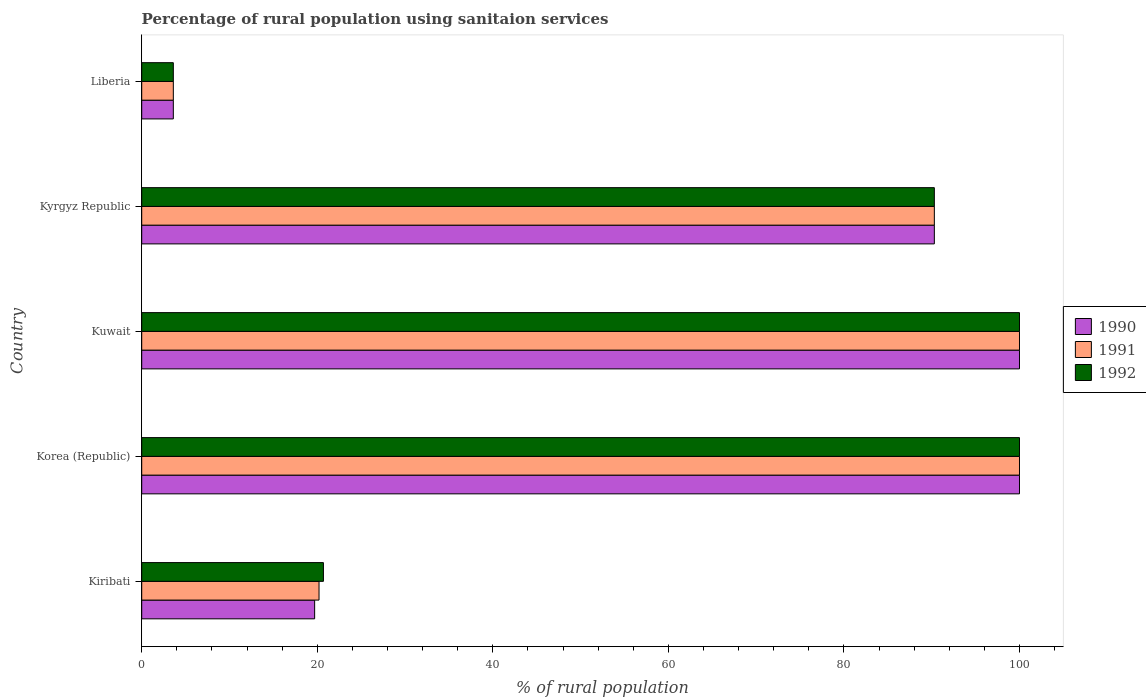Are the number of bars on each tick of the Y-axis equal?
Keep it short and to the point. Yes. How many bars are there on the 3rd tick from the top?
Make the answer very short. 3. How many bars are there on the 3rd tick from the bottom?
Your response must be concise. 3. What is the label of the 3rd group of bars from the top?
Your answer should be compact. Kuwait. What is the percentage of rural population using sanitaion services in 1990 in Kuwait?
Offer a very short reply. 100. In which country was the percentage of rural population using sanitaion services in 1992 maximum?
Offer a terse response. Korea (Republic). In which country was the percentage of rural population using sanitaion services in 1990 minimum?
Keep it short and to the point. Liberia. What is the total percentage of rural population using sanitaion services in 1992 in the graph?
Make the answer very short. 314.6. What is the difference between the percentage of rural population using sanitaion services in 1991 in Korea (Republic) and that in Kyrgyz Republic?
Offer a terse response. 9.7. What is the difference between the percentage of rural population using sanitaion services in 1991 in Kiribati and the percentage of rural population using sanitaion services in 1992 in Kyrgyz Republic?
Your answer should be compact. -70.1. What is the average percentage of rural population using sanitaion services in 1992 per country?
Make the answer very short. 62.92. What is the difference between the percentage of rural population using sanitaion services in 1990 and percentage of rural population using sanitaion services in 1992 in Liberia?
Your answer should be compact. 0. In how many countries, is the percentage of rural population using sanitaion services in 1990 greater than 44 %?
Ensure brevity in your answer.  3. What is the ratio of the percentage of rural population using sanitaion services in 1991 in Kuwait to that in Liberia?
Offer a terse response. 27.78. Is the percentage of rural population using sanitaion services in 1990 in Kiribati less than that in Liberia?
Provide a succinct answer. No. What is the difference between the highest and the second highest percentage of rural population using sanitaion services in 1991?
Make the answer very short. 0. What is the difference between the highest and the lowest percentage of rural population using sanitaion services in 1990?
Make the answer very short. 96.4. In how many countries, is the percentage of rural population using sanitaion services in 1992 greater than the average percentage of rural population using sanitaion services in 1992 taken over all countries?
Provide a succinct answer. 3. What does the 2nd bar from the bottom in Kiribati represents?
Give a very brief answer. 1991. Is it the case that in every country, the sum of the percentage of rural population using sanitaion services in 1992 and percentage of rural population using sanitaion services in 1990 is greater than the percentage of rural population using sanitaion services in 1991?
Ensure brevity in your answer.  Yes. How many bars are there?
Make the answer very short. 15. Are all the bars in the graph horizontal?
Your response must be concise. Yes. What is the difference between two consecutive major ticks on the X-axis?
Your answer should be very brief. 20. Does the graph contain any zero values?
Your response must be concise. No. Where does the legend appear in the graph?
Your answer should be compact. Center right. How many legend labels are there?
Ensure brevity in your answer.  3. What is the title of the graph?
Keep it short and to the point. Percentage of rural population using sanitaion services. What is the label or title of the X-axis?
Ensure brevity in your answer.  % of rural population. What is the % of rural population in 1991 in Kiribati?
Make the answer very short. 20.2. What is the % of rural population of 1992 in Kiribati?
Provide a short and direct response. 20.7. What is the % of rural population in 1990 in Korea (Republic)?
Ensure brevity in your answer.  100. What is the % of rural population in 1992 in Korea (Republic)?
Ensure brevity in your answer.  100. What is the % of rural population of 1990 in Kuwait?
Provide a short and direct response. 100. What is the % of rural population of 1992 in Kuwait?
Your answer should be compact. 100. What is the % of rural population of 1990 in Kyrgyz Republic?
Offer a terse response. 90.3. What is the % of rural population in 1991 in Kyrgyz Republic?
Ensure brevity in your answer.  90.3. What is the % of rural population of 1992 in Kyrgyz Republic?
Your response must be concise. 90.3. What is the % of rural population of 1990 in Liberia?
Provide a succinct answer. 3.6. Across all countries, what is the maximum % of rural population in 1991?
Your response must be concise. 100. Across all countries, what is the maximum % of rural population of 1992?
Keep it short and to the point. 100. Across all countries, what is the minimum % of rural population in 1991?
Your answer should be compact. 3.6. Across all countries, what is the minimum % of rural population of 1992?
Your answer should be compact. 3.6. What is the total % of rural population of 1990 in the graph?
Your response must be concise. 313.6. What is the total % of rural population of 1991 in the graph?
Your response must be concise. 314.1. What is the total % of rural population of 1992 in the graph?
Keep it short and to the point. 314.6. What is the difference between the % of rural population of 1990 in Kiribati and that in Korea (Republic)?
Ensure brevity in your answer.  -80.3. What is the difference between the % of rural population of 1991 in Kiribati and that in Korea (Republic)?
Your answer should be compact. -79.8. What is the difference between the % of rural population in 1992 in Kiribati and that in Korea (Republic)?
Give a very brief answer. -79.3. What is the difference between the % of rural population in 1990 in Kiribati and that in Kuwait?
Ensure brevity in your answer.  -80.3. What is the difference between the % of rural population in 1991 in Kiribati and that in Kuwait?
Provide a short and direct response. -79.8. What is the difference between the % of rural population in 1992 in Kiribati and that in Kuwait?
Provide a short and direct response. -79.3. What is the difference between the % of rural population in 1990 in Kiribati and that in Kyrgyz Republic?
Ensure brevity in your answer.  -70.6. What is the difference between the % of rural population in 1991 in Kiribati and that in Kyrgyz Republic?
Your answer should be compact. -70.1. What is the difference between the % of rural population in 1992 in Kiribati and that in Kyrgyz Republic?
Your response must be concise. -69.6. What is the difference between the % of rural population in 1990 in Korea (Republic) and that in Kuwait?
Provide a short and direct response. 0. What is the difference between the % of rural population in 1991 in Korea (Republic) and that in Kuwait?
Make the answer very short. 0. What is the difference between the % of rural population of 1992 in Korea (Republic) and that in Kuwait?
Keep it short and to the point. 0. What is the difference between the % of rural population in 1990 in Korea (Republic) and that in Kyrgyz Republic?
Offer a very short reply. 9.7. What is the difference between the % of rural population of 1991 in Korea (Republic) and that in Kyrgyz Republic?
Your answer should be very brief. 9.7. What is the difference between the % of rural population of 1992 in Korea (Republic) and that in Kyrgyz Republic?
Your answer should be very brief. 9.7. What is the difference between the % of rural population of 1990 in Korea (Republic) and that in Liberia?
Make the answer very short. 96.4. What is the difference between the % of rural population in 1991 in Korea (Republic) and that in Liberia?
Provide a succinct answer. 96.4. What is the difference between the % of rural population in 1992 in Korea (Republic) and that in Liberia?
Your answer should be very brief. 96.4. What is the difference between the % of rural population in 1990 in Kuwait and that in Kyrgyz Republic?
Your response must be concise. 9.7. What is the difference between the % of rural population of 1991 in Kuwait and that in Kyrgyz Republic?
Your answer should be compact. 9.7. What is the difference between the % of rural population in 1992 in Kuwait and that in Kyrgyz Republic?
Keep it short and to the point. 9.7. What is the difference between the % of rural population in 1990 in Kuwait and that in Liberia?
Keep it short and to the point. 96.4. What is the difference between the % of rural population of 1991 in Kuwait and that in Liberia?
Offer a terse response. 96.4. What is the difference between the % of rural population in 1992 in Kuwait and that in Liberia?
Your response must be concise. 96.4. What is the difference between the % of rural population in 1990 in Kyrgyz Republic and that in Liberia?
Offer a terse response. 86.7. What is the difference between the % of rural population of 1991 in Kyrgyz Republic and that in Liberia?
Give a very brief answer. 86.7. What is the difference between the % of rural population of 1992 in Kyrgyz Republic and that in Liberia?
Keep it short and to the point. 86.7. What is the difference between the % of rural population of 1990 in Kiribati and the % of rural population of 1991 in Korea (Republic)?
Give a very brief answer. -80.3. What is the difference between the % of rural population in 1990 in Kiribati and the % of rural population in 1992 in Korea (Republic)?
Provide a short and direct response. -80.3. What is the difference between the % of rural population in 1991 in Kiribati and the % of rural population in 1992 in Korea (Republic)?
Offer a very short reply. -79.8. What is the difference between the % of rural population of 1990 in Kiribati and the % of rural population of 1991 in Kuwait?
Keep it short and to the point. -80.3. What is the difference between the % of rural population of 1990 in Kiribati and the % of rural population of 1992 in Kuwait?
Offer a terse response. -80.3. What is the difference between the % of rural population in 1991 in Kiribati and the % of rural population in 1992 in Kuwait?
Your response must be concise. -79.8. What is the difference between the % of rural population in 1990 in Kiribati and the % of rural population in 1991 in Kyrgyz Republic?
Offer a terse response. -70.6. What is the difference between the % of rural population of 1990 in Kiribati and the % of rural population of 1992 in Kyrgyz Republic?
Your answer should be compact. -70.6. What is the difference between the % of rural population in 1991 in Kiribati and the % of rural population in 1992 in Kyrgyz Republic?
Offer a terse response. -70.1. What is the difference between the % of rural population in 1991 in Korea (Republic) and the % of rural population in 1992 in Kuwait?
Make the answer very short. 0. What is the difference between the % of rural population in 1990 in Korea (Republic) and the % of rural population in 1991 in Kyrgyz Republic?
Your answer should be very brief. 9.7. What is the difference between the % of rural population of 1991 in Korea (Republic) and the % of rural population of 1992 in Kyrgyz Republic?
Offer a very short reply. 9.7. What is the difference between the % of rural population in 1990 in Korea (Republic) and the % of rural population in 1991 in Liberia?
Make the answer very short. 96.4. What is the difference between the % of rural population in 1990 in Korea (Republic) and the % of rural population in 1992 in Liberia?
Ensure brevity in your answer.  96.4. What is the difference between the % of rural population in 1991 in Korea (Republic) and the % of rural population in 1992 in Liberia?
Provide a succinct answer. 96.4. What is the difference between the % of rural population in 1990 in Kuwait and the % of rural population in 1991 in Kyrgyz Republic?
Provide a short and direct response. 9.7. What is the difference between the % of rural population in 1991 in Kuwait and the % of rural population in 1992 in Kyrgyz Republic?
Provide a succinct answer. 9.7. What is the difference between the % of rural population in 1990 in Kuwait and the % of rural population in 1991 in Liberia?
Your answer should be compact. 96.4. What is the difference between the % of rural population in 1990 in Kuwait and the % of rural population in 1992 in Liberia?
Your answer should be very brief. 96.4. What is the difference between the % of rural population of 1991 in Kuwait and the % of rural population of 1992 in Liberia?
Your answer should be compact. 96.4. What is the difference between the % of rural population of 1990 in Kyrgyz Republic and the % of rural population of 1991 in Liberia?
Your answer should be compact. 86.7. What is the difference between the % of rural population of 1990 in Kyrgyz Republic and the % of rural population of 1992 in Liberia?
Your answer should be compact. 86.7. What is the difference between the % of rural population in 1991 in Kyrgyz Republic and the % of rural population in 1992 in Liberia?
Your answer should be very brief. 86.7. What is the average % of rural population of 1990 per country?
Provide a short and direct response. 62.72. What is the average % of rural population of 1991 per country?
Make the answer very short. 62.82. What is the average % of rural population of 1992 per country?
Your response must be concise. 62.92. What is the difference between the % of rural population of 1990 and % of rural population of 1991 in Kiribati?
Provide a succinct answer. -0.5. What is the difference between the % of rural population of 1990 and % of rural population of 1992 in Korea (Republic)?
Give a very brief answer. 0. What is the difference between the % of rural population in 1990 and % of rural population in 1992 in Kuwait?
Make the answer very short. 0. What is the difference between the % of rural population in 1991 and % of rural population in 1992 in Kuwait?
Offer a very short reply. 0. What is the difference between the % of rural population in 1990 and % of rural population in 1991 in Kyrgyz Republic?
Offer a terse response. 0. What is the difference between the % of rural population in 1990 and % of rural population in 1991 in Liberia?
Your response must be concise. 0. What is the ratio of the % of rural population of 1990 in Kiribati to that in Korea (Republic)?
Offer a very short reply. 0.2. What is the ratio of the % of rural population in 1991 in Kiribati to that in Korea (Republic)?
Provide a short and direct response. 0.2. What is the ratio of the % of rural population in 1992 in Kiribati to that in Korea (Republic)?
Make the answer very short. 0.21. What is the ratio of the % of rural population of 1990 in Kiribati to that in Kuwait?
Your answer should be compact. 0.2. What is the ratio of the % of rural population of 1991 in Kiribati to that in Kuwait?
Your response must be concise. 0.2. What is the ratio of the % of rural population in 1992 in Kiribati to that in Kuwait?
Provide a short and direct response. 0.21. What is the ratio of the % of rural population in 1990 in Kiribati to that in Kyrgyz Republic?
Provide a short and direct response. 0.22. What is the ratio of the % of rural population in 1991 in Kiribati to that in Kyrgyz Republic?
Offer a very short reply. 0.22. What is the ratio of the % of rural population in 1992 in Kiribati to that in Kyrgyz Republic?
Offer a very short reply. 0.23. What is the ratio of the % of rural population of 1990 in Kiribati to that in Liberia?
Ensure brevity in your answer.  5.47. What is the ratio of the % of rural population in 1991 in Kiribati to that in Liberia?
Your answer should be very brief. 5.61. What is the ratio of the % of rural population in 1992 in Kiribati to that in Liberia?
Offer a very short reply. 5.75. What is the ratio of the % of rural population in 1991 in Korea (Republic) to that in Kuwait?
Provide a succinct answer. 1. What is the ratio of the % of rural population of 1990 in Korea (Republic) to that in Kyrgyz Republic?
Make the answer very short. 1.11. What is the ratio of the % of rural population in 1991 in Korea (Republic) to that in Kyrgyz Republic?
Offer a very short reply. 1.11. What is the ratio of the % of rural population in 1992 in Korea (Republic) to that in Kyrgyz Republic?
Offer a terse response. 1.11. What is the ratio of the % of rural population in 1990 in Korea (Republic) to that in Liberia?
Provide a short and direct response. 27.78. What is the ratio of the % of rural population in 1991 in Korea (Republic) to that in Liberia?
Your answer should be compact. 27.78. What is the ratio of the % of rural population of 1992 in Korea (Republic) to that in Liberia?
Your answer should be very brief. 27.78. What is the ratio of the % of rural population in 1990 in Kuwait to that in Kyrgyz Republic?
Offer a very short reply. 1.11. What is the ratio of the % of rural population in 1991 in Kuwait to that in Kyrgyz Republic?
Give a very brief answer. 1.11. What is the ratio of the % of rural population in 1992 in Kuwait to that in Kyrgyz Republic?
Your response must be concise. 1.11. What is the ratio of the % of rural population of 1990 in Kuwait to that in Liberia?
Offer a very short reply. 27.78. What is the ratio of the % of rural population of 1991 in Kuwait to that in Liberia?
Offer a terse response. 27.78. What is the ratio of the % of rural population of 1992 in Kuwait to that in Liberia?
Ensure brevity in your answer.  27.78. What is the ratio of the % of rural population in 1990 in Kyrgyz Republic to that in Liberia?
Make the answer very short. 25.08. What is the ratio of the % of rural population of 1991 in Kyrgyz Republic to that in Liberia?
Provide a short and direct response. 25.08. What is the ratio of the % of rural population of 1992 in Kyrgyz Republic to that in Liberia?
Your answer should be very brief. 25.08. What is the difference between the highest and the second highest % of rural population of 1991?
Provide a short and direct response. 0. What is the difference between the highest and the lowest % of rural population of 1990?
Make the answer very short. 96.4. What is the difference between the highest and the lowest % of rural population in 1991?
Ensure brevity in your answer.  96.4. What is the difference between the highest and the lowest % of rural population in 1992?
Ensure brevity in your answer.  96.4. 